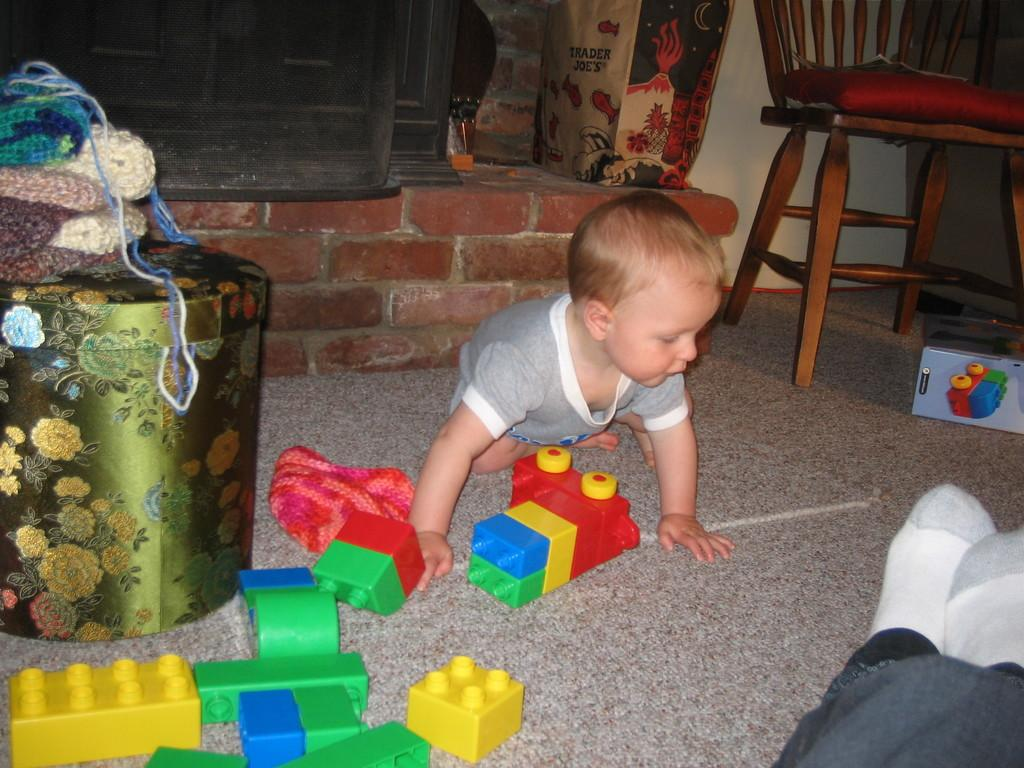What is the position of the kid in the image? The kid is sitting on the ground. What is the kid wearing in the image? The kid is wearing clothes. What objects are on the ground near the kid? There are toys and a container on the ground. What items can be seen in front of the wall? There is a bag and a chair in front of the wall. What type of guitar is the beggar playing in the image? There is no beggar or guitar present in the image. Can you see any branches in the image? There are no branches visible in the image. 